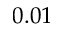<formula> <loc_0><loc_0><loc_500><loc_500>0 . 0 1</formula> 